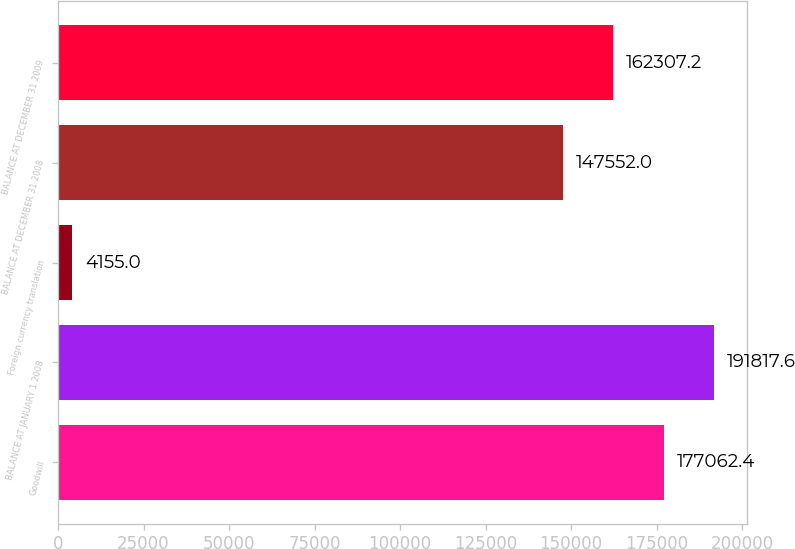Convert chart. <chart><loc_0><loc_0><loc_500><loc_500><bar_chart><fcel>Goodwill<fcel>BALANCE AT JANUARY 1 2008<fcel>Foreign currency translation<fcel>BALANCE AT DECEMBER 31 2008<fcel>BALANCE AT DECEMBER 31 2009<nl><fcel>177062<fcel>191818<fcel>4155<fcel>147552<fcel>162307<nl></chart> 